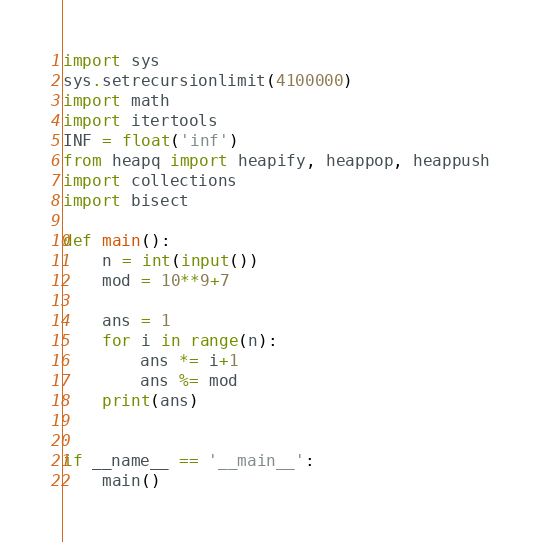Convert code to text. <code><loc_0><loc_0><loc_500><loc_500><_Python_>import sys
sys.setrecursionlimit(4100000)
import math
import itertools
INF = float('inf')
from heapq import heapify, heappop, heappush
import collections
import bisect

def main():
    n = int(input())
    mod = 10**9+7

    ans = 1
    for i in range(n):
        ans *= i+1
        ans %= mod
    print(ans)


if __name__ == '__main__':
    main()
</code> 